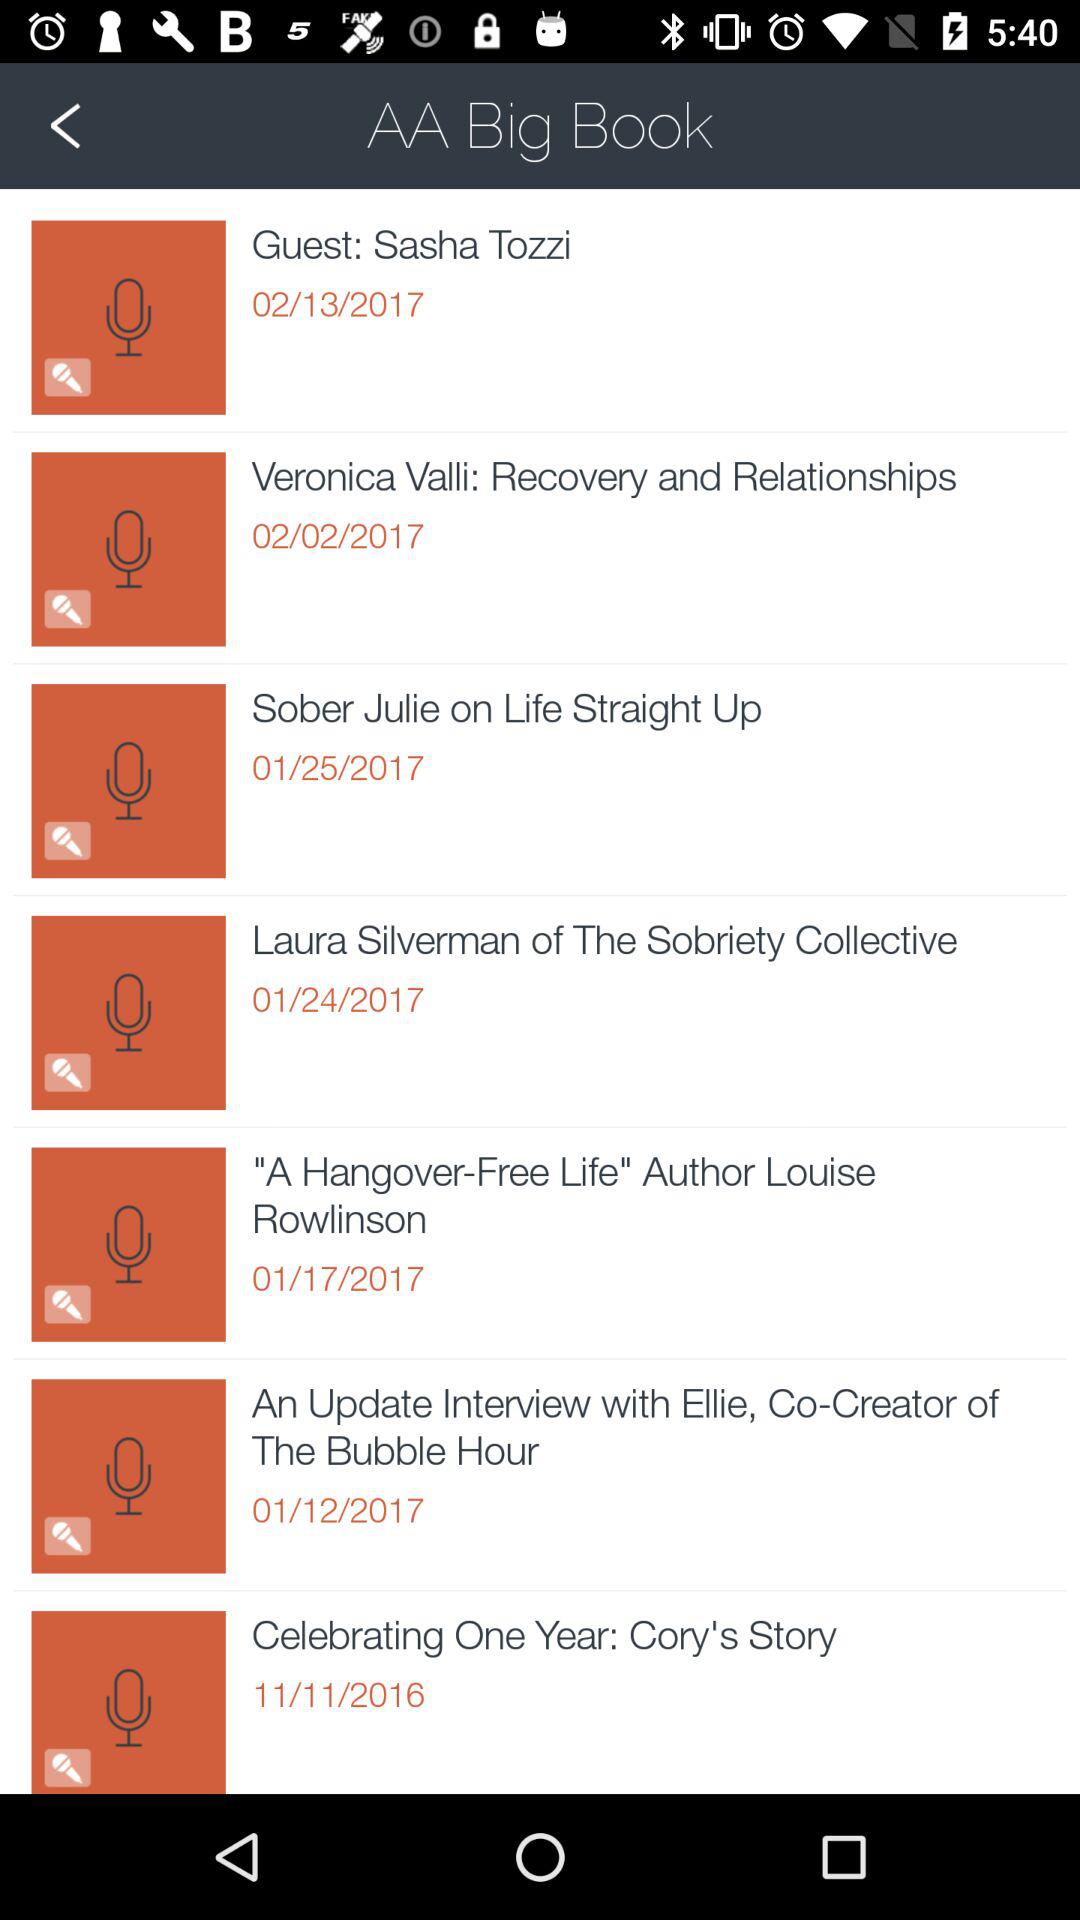What is the date for "Guest: Sasha Tozzi"? The date for "Guest: Sasha Tozzi" is February 13, 2017. 